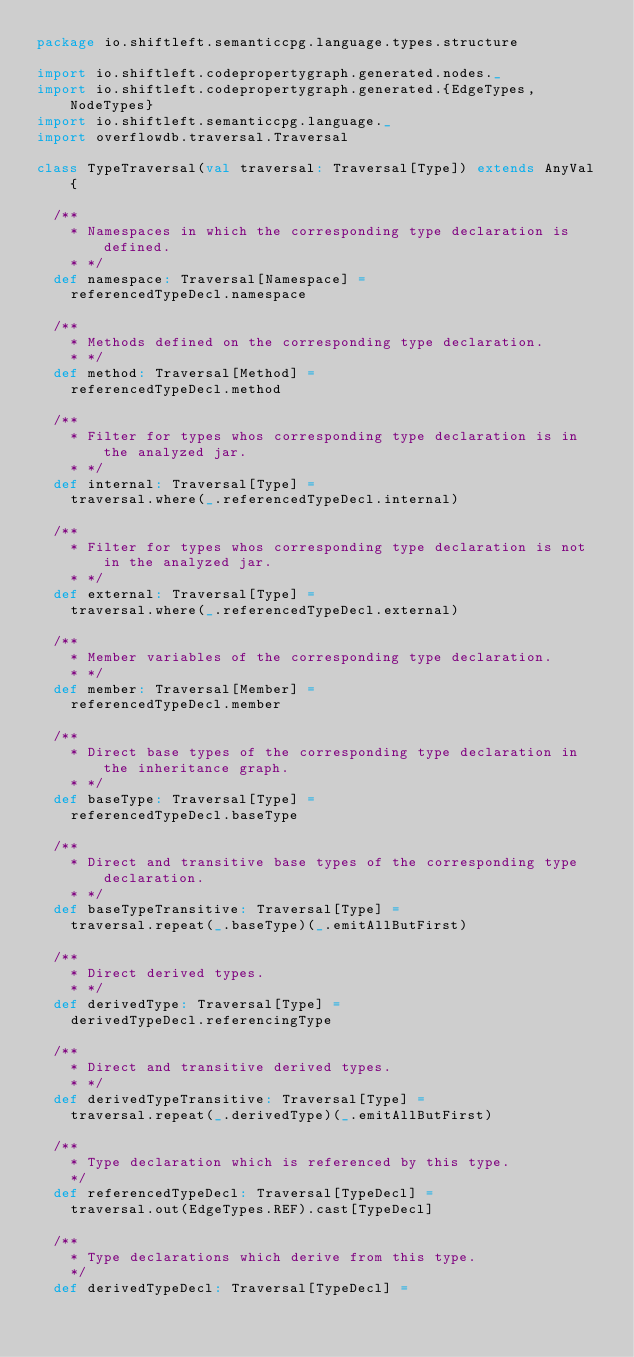<code> <loc_0><loc_0><loc_500><loc_500><_Scala_>package io.shiftleft.semanticcpg.language.types.structure

import io.shiftleft.codepropertygraph.generated.nodes._
import io.shiftleft.codepropertygraph.generated.{EdgeTypes, NodeTypes}
import io.shiftleft.semanticcpg.language._
import overflowdb.traversal.Traversal

class TypeTraversal(val traversal: Traversal[Type]) extends AnyVal {

  /**
    * Namespaces in which the corresponding type declaration is defined.
    * */
  def namespace: Traversal[Namespace] =
    referencedTypeDecl.namespace

  /**
    * Methods defined on the corresponding type declaration.
    * */
  def method: Traversal[Method] =
    referencedTypeDecl.method

  /**
    * Filter for types whos corresponding type declaration is in the analyzed jar.
    * */
  def internal: Traversal[Type] =
    traversal.where(_.referencedTypeDecl.internal)

  /**
    * Filter for types whos corresponding type declaration is not in the analyzed jar.
    * */
  def external: Traversal[Type] =
    traversal.where(_.referencedTypeDecl.external)

  /**
    * Member variables of the corresponding type declaration.
    * */
  def member: Traversal[Member] =
    referencedTypeDecl.member

  /**
    * Direct base types of the corresponding type declaration in the inheritance graph.
    * */
  def baseType: Traversal[Type] =
    referencedTypeDecl.baseType

  /**
    * Direct and transitive base types of the corresponding type declaration.
    * */
  def baseTypeTransitive: Traversal[Type] =
    traversal.repeat(_.baseType)(_.emitAllButFirst)

  /**
    * Direct derived types.
    * */
  def derivedType: Traversal[Type] =
    derivedTypeDecl.referencingType

  /**
    * Direct and transitive derived types.
    * */
  def derivedTypeTransitive: Traversal[Type] =
    traversal.repeat(_.derivedType)(_.emitAllButFirst)

  /**
    * Type declaration which is referenced by this type.
    */
  def referencedTypeDecl: Traversal[TypeDecl] =
    traversal.out(EdgeTypes.REF).cast[TypeDecl]

  /**
    * Type declarations which derive from this type.
    */
  def derivedTypeDecl: Traversal[TypeDecl] =</code> 